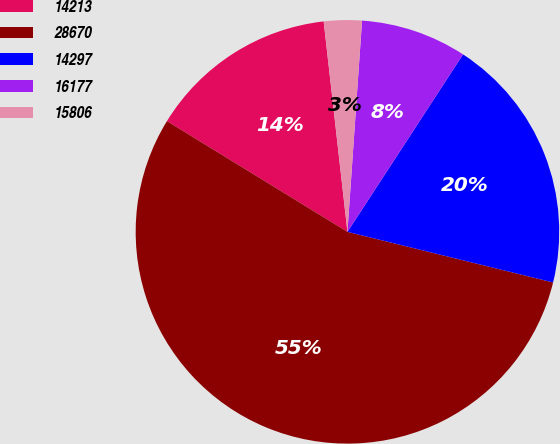<chart> <loc_0><loc_0><loc_500><loc_500><pie_chart><fcel>14213<fcel>28670<fcel>14297<fcel>16177<fcel>15806<nl><fcel>14.45%<fcel>54.91%<fcel>19.65%<fcel>8.09%<fcel>2.89%<nl></chart> 